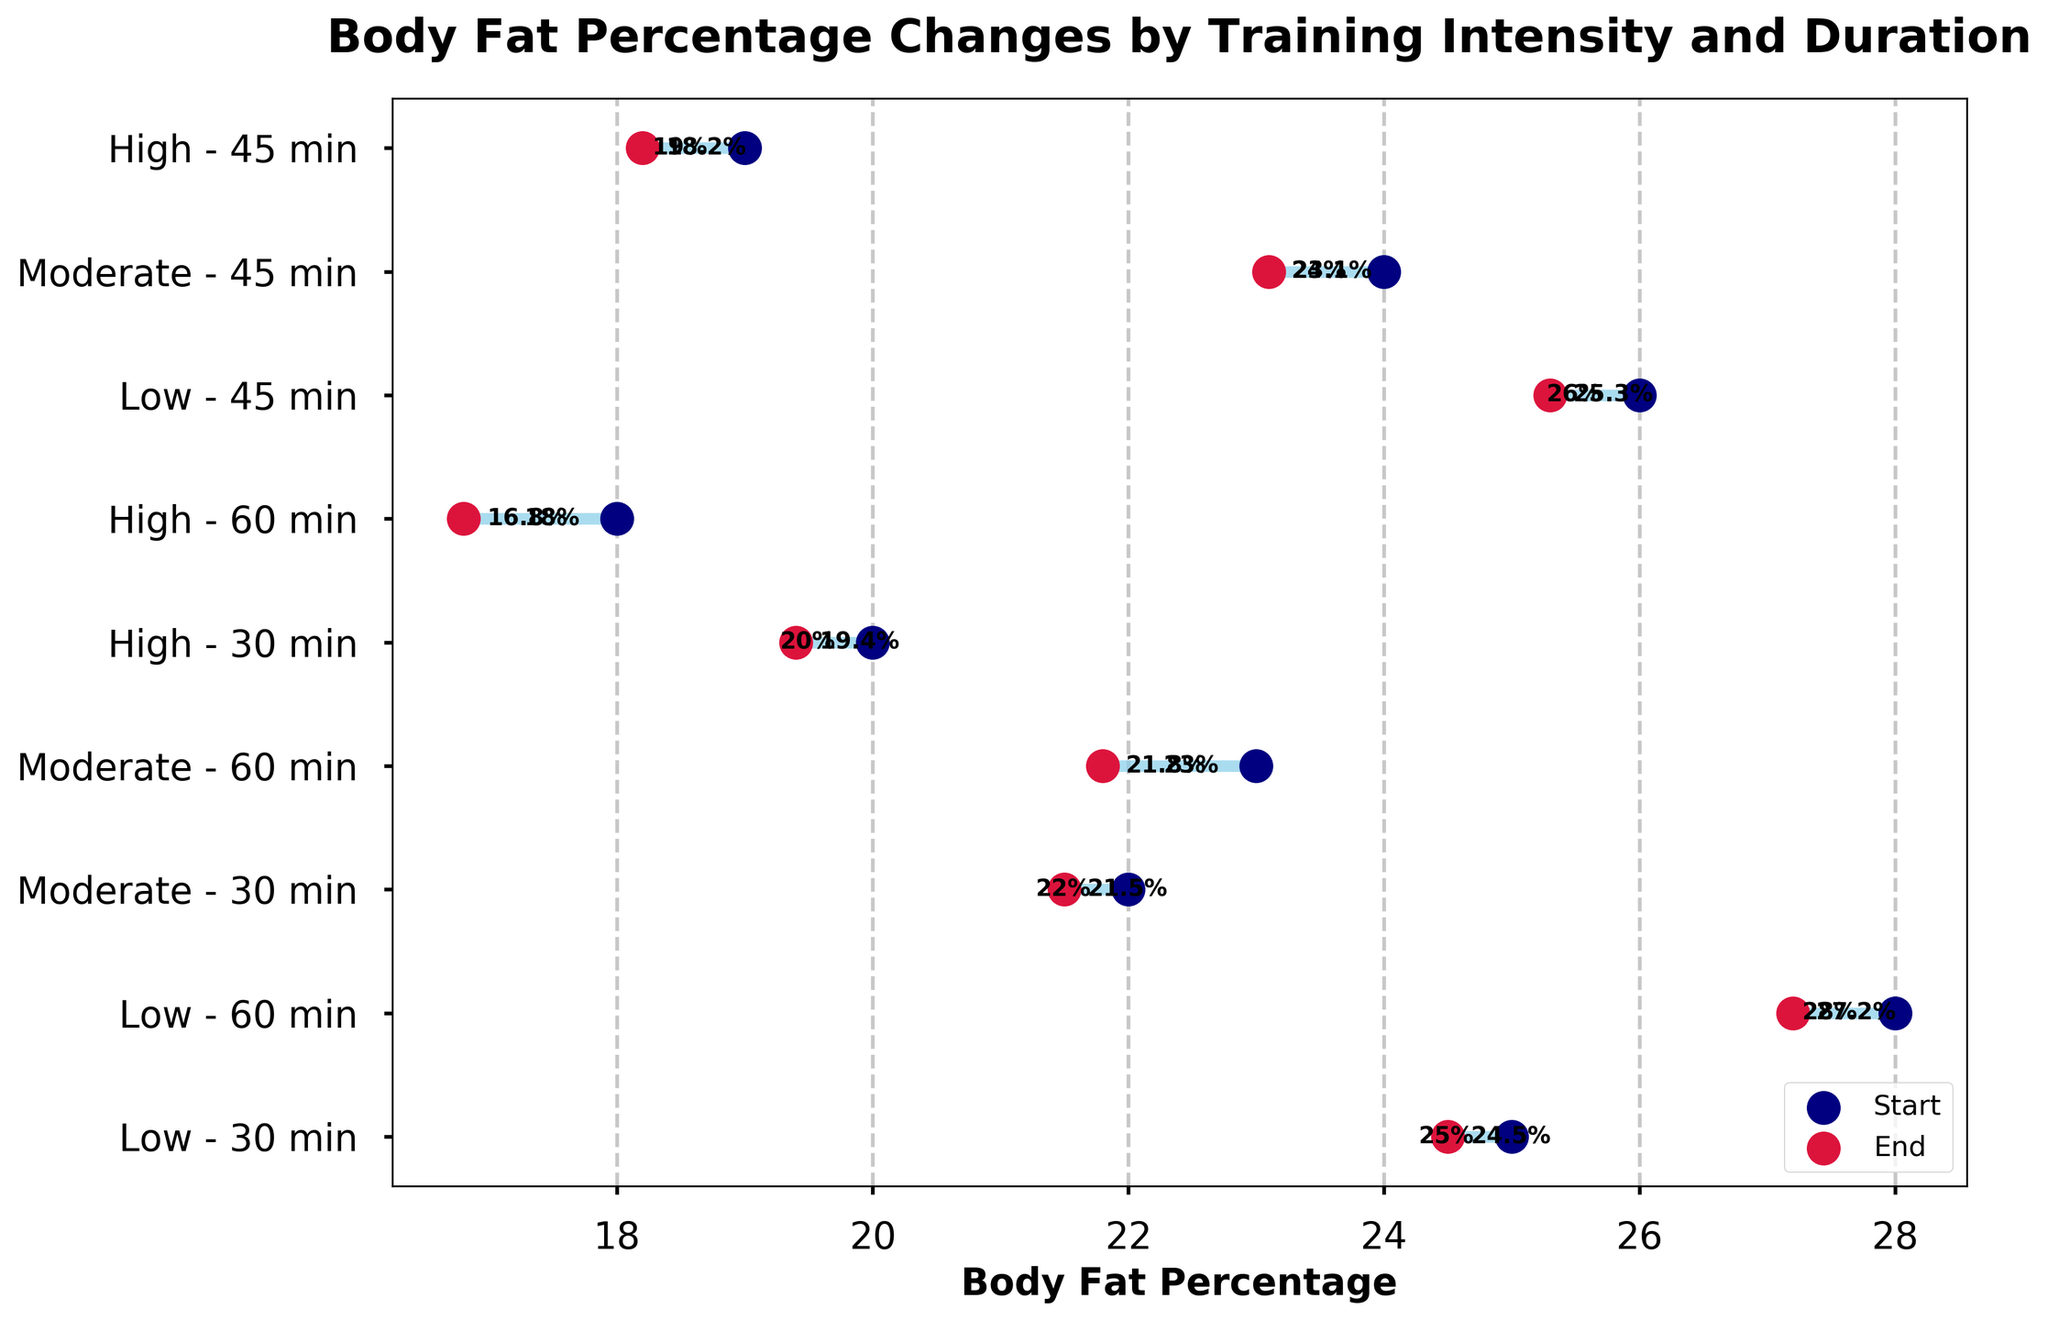What's the title of the figure? The title of the figure is usually located at the top of the chart, which describes the overall concept or focus of the data presented.
Answer: Body Fat Percentage Changes by Training Intensity and Duration What does the horizontal line represent in the figure? Each horizontal line connects the start and end body fat percentages for a participant, indicating the change over the specified training period.
Answer: Change in body fat percentage Which participant saw the largest decrease in body fat percentage? To determine this, find the longest horizontal line segment where the end percentage is significantly lower than the start percentage.
Answer: Olivia Brown How many participants are there in the study? Each horizontal line represents a unique participant. By counting these lines, we can find the total number of participants.
Answer: 9 What can we infer about low intensity training of 60 minutes from the figure? Locate the segment labeled "Low - 60 min." Reference the start and end points of the horizontal line, then compare these points to identify any changes.
Answer: Jane Smith saw a decrease from 28% to 27.2% Which training intensity appears to have the most significant impact on reducing body fat percentage? Compare the magnitude of changes (length of line segments) across different training intensities (low, moderate, high). The largest reductions are indicative of the most impact.
Answer: High intensity What's the average reduction in body fat percentage for moderate intensity training of 45 minutes? Identify the starting and ending body fat percentages for moderate intensity training of 45 minutes. Then, calculate the difference for each participant involved and find the average reduction.
Answer: (24 - 23.1) / 1 = 0.9% Is there a visible correlation between training duration and body fat percentage reduction for high intensity training? Compare the changes in body fat percentage (line lengths) for high intensity across different durations (30, 45, 60 minutes) to identify any patterns in reduction relative to time.
Answer: Yes, longer durations appear to result in greater reductions Which participant had the smallest change in body fat percentage, and what was the specific change? Compare all the horizontal line segments to find the shortest one, indicating the smallest change.
Answer: Michael Johnson (0.5%) Does moderate intensity training for 60 minutes result in a greater reduction in body fat percentage compared to low intensity training for 60 minutes? Compare the line segments corresponding to "Moderate - 60 min" and "Low - 60 min". Check the start and end points to see which has a larger reduction.
Answer: Yes, 1.2% for moderate vs. 0.8% for low 